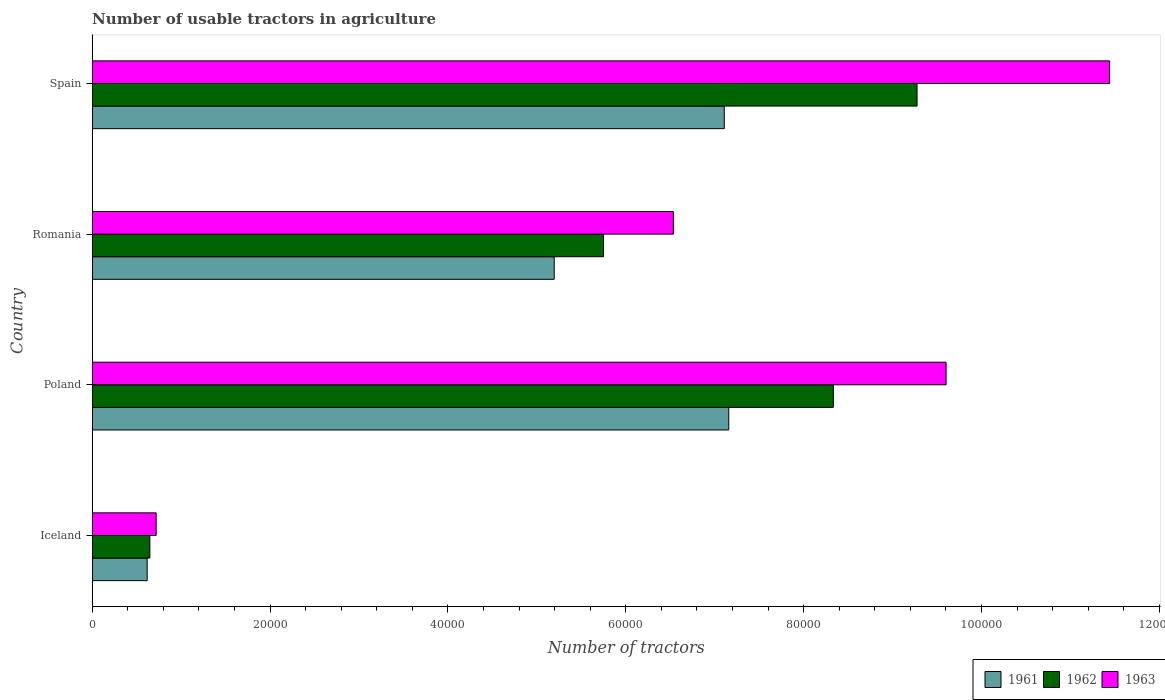How many different coloured bars are there?
Your answer should be compact. 3. Are the number of bars on each tick of the Y-axis equal?
Offer a very short reply. Yes. How many bars are there on the 4th tick from the top?
Offer a terse response. 3. What is the number of usable tractors in agriculture in 1961 in Spain?
Keep it short and to the point. 7.11e+04. Across all countries, what is the maximum number of usable tractors in agriculture in 1963?
Offer a terse response. 1.14e+05. Across all countries, what is the minimum number of usable tractors in agriculture in 1961?
Provide a short and direct response. 6177. In which country was the number of usable tractors in agriculture in 1961 minimum?
Keep it short and to the point. Iceland. What is the total number of usable tractors in agriculture in 1963 in the graph?
Make the answer very short. 2.83e+05. What is the difference between the number of usable tractors in agriculture in 1963 in Iceland and that in Poland?
Keep it short and to the point. -8.88e+04. What is the difference between the number of usable tractors in agriculture in 1961 in Spain and the number of usable tractors in agriculture in 1962 in Iceland?
Keep it short and to the point. 6.46e+04. What is the average number of usable tractors in agriculture in 1962 per country?
Your response must be concise. 6.00e+04. What is the difference between the number of usable tractors in agriculture in 1962 and number of usable tractors in agriculture in 1961 in Iceland?
Make the answer very short. 302. What is the ratio of the number of usable tractors in agriculture in 1961 in Iceland to that in Poland?
Your answer should be very brief. 0.09. Is the difference between the number of usable tractors in agriculture in 1962 in Poland and Spain greater than the difference between the number of usable tractors in agriculture in 1961 in Poland and Spain?
Your answer should be very brief. No. What is the difference between the highest and the lowest number of usable tractors in agriculture in 1961?
Give a very brief answer. 6.54e+04. Is the sum of the number of usable tractors in agriculture in 1961 in Iceland and Spain greater than the maximum number of usable tractors in agriculture in 1962 across all countries?
Your answer should be very brief. No. What does the 3rd bar from the top in Romania represents?
Make the answer very short. 1961. Is it the case that in every country, the sum of the number of usable tractors in agriculture in 1962 and number of usable tractors in agriculture in 1963 is greater than the number of usable tractors in agriculture in 1961?
Keep it short and to the point. Yes. Are all the bars in the graph horizontal?
Keep it short and to the point. Yes. How many countries are there in the graph?
Keep it short and to the point. 4. What is the difference between two consecutive major ticks on the X-axis?
Provide a short and direct response. 2.00e+04. Are the values on the major ticks of X-axis written in scientific E-notation?
Your answer should be very brief. No. Does the graph contain any zero values?
Offer a very short reply. No. Does the graph contain grids?
Your answer should be very brief. No. Where does the legend appear in the graph?
Offer a very short reply. Bottom right. How are the legend labels stacked?
Give a very brief answer. Horizontal. What is the title of the graph?
Make the answer very short. Number of usable tractors in agriculture. What is the label or title of the X-axis?
Offer a very short reply. Number of tractors. What is the Number of tractors in 1961 in Iceland?
Keep it short and to the point. 6177. What is the Number of tractors of 1962 in Iceland?
Offer a terse response. 6479. What is the Number of tractors in 1963 in Iceland?
Offer a very short reply. 7187. What is the Number of tractors of 1961 in Poland?
Your answer should be compact. 7.16e+04. What is the Number of tractors of 1962 in Poland?
Offer a very short reply. 8.33e+04. What is the Number of tractors in 1963 in Poland?
Provide a short and direct response. 9.60e+04. What is the Number of tractors in 1961 in Romania?
Give a very brief answer. 5.20e+04. What is the Number of tractors in 1962 in Romania?
Provide a short and direct response. 5.75e+04. What is the Number of tractors in 1963 in Romania?
Ensure brevity in your answer.  6.54e+04. What is the Number of tractors of 1961 in Spain?
Give a very brief answer. 7.11e+04. What is the Number of tractors in 1962 in Spain?
Offer a very short reply. 9.28e+04. What is the Number of tractors of 1963 in Spain?
Give a very brief answer. 1.14e+05. Across all countries, what is the maximum Number of tractors in 1961?
Provide a short and direct response. 7.16e+04. Across all countries, what is the maximum Number of tractors in 1962?
Provide a succinct answer. 9.28e+04. Across all countries, what is the maximum Number of tractors in 1963?
Your answer should be compact. 1.14e+05. Across all countries, what is the minimum Number of tractors of 1961?
Give a very brief answer. 6177. Across all countries, what is the minimum Number of tractors of 1962?
Your answer should be compact. 6479. Across all countries, what is the minimum Number of tractors in 1963?
Your answer should be very brief. 7187. What is the total Number of tractors of 1961 in the graph?
Make the answer very short. 2.01e+05. What is the total Number of tractors of 1962 in the graph?
Your answer should be very brief. 2.40e+05. What is the total Number of tractors of 1963 in the graph?
Offer a very short reply. 2.83e+05. What is the difference between the Number of tractors in 1961 in Iceland and that in Poland?
Offer a terse response. -6.54e+04. What is the difference between the Number of tractors in 1962 in Iceland and that in Poland?
Your response must be concise. -7.69e+04. What is the difference between the Number of tractors in 1963 in Iceland and that in Poland?
Provide a short and direct response. -8.88e+04. What is the difference between the Number of tractors of 1961 in Iceland and that in Romania?
Your response must be concise. -4.58e+04. What is the difference between the Number of tractors in 1962 in Iceland and that in Romania?
Your answer should be very brief. -5.10e+04. What is the difference between the Number of tractors of 1963 in Iceland and that in Romania?
Give a very brief answer. -5.82e+04. What is the difference between the Number of tractors of 1961 in Iceland and that in Spain?
Ensure brevity in your answer.  -6.49e+04. What is the difference between the Number of tractors of 1962 in Iceland and that in Spain?
Your answer should be very brief. -8.63e+04. What is the difference between the Number of tractors in 1963 in Iceland and that in Spain?
Keep it short and to the point. -1.07e+05. What is the difference between the Number of tractors of 1961 in Poland and that in Romania?
Provide a short and direct response. 1.96e+04. What is the difference between the Number of tractors of 1962 in Poland and that in Romania?
Your answer should be compact. 2.58e+04. What is the difference between the Number of tractors in 1963 in Poland and that in Romania?
Your response must be concise. 3.07e+04. What is the difference between the Number of tractors of 1962 in Poland and that in Spain?
Offer a terse response. -9414. What is the difference between the Number of tractors in 1963 in Poland and that in Spain?
Give a very brief answer. -1.84e+04. What is the difference between the Number of tractors of 1961 in Romania and that in Spain?
Ensure brevity in your answer.  -1.91e+04. What is the difference between the Number of tractors in 1962 in Romania and that in Spain?
Give a very brief answer. -3.53e+04. What is the difference between the Number of tractors of 1963 in Romania and that in Spain?
Offer a very short reply. -4.91e+04. What is the difference between the Number of tractors in 1961 in Iceland and the Number of tractors in 1962 in Poland?
Your response must be concise. -7.72e+04. What is the difference between the Number of tractors in 1961 in Iceland and the Number of tractors in 1963 in Poland?
Keep it short and to the point. -8.98e+04. What is the difference between the Number of tractors of 1962 in Iceland and the Number of tractors of 1963 in Poland?
Give a very brief answer. -8.95e+04. What is the difference between the Number of tractors of 1961 in Iceland and the Number of tractors of 1962 in Romania?
Your answer should be very brief. -5.13e+04. What is the difference between the Number of tractors of 1961 in Iceland and the Number of tractors of 1963 in Romania?
Make the answer very short. -5.92e+04. What is the difference between the Number of tractors of 1962 in Iceland and the Number of tractors of 1963 in Romania?
Your answer should be compact. -5.89e+04. What is the difference between the Number of tractors of 1961 in Iceland and the Number of tractors of 1962 in Spain?
Your response must be concise. -8.66e+04. What is the difference between the Number of tractors of 1961 in Iceland and the Number of tractors of 1963 in Spain?
Offer a very short reply. -1.08e+05. What is the difference between the Number of tractors of 1962 in Iceland and the Number of tractors of 1963 in Spain?
Your response must be concise. -1.08e+05. What is the difference between the Number of tractors of 1961 in Poland and the Number of tractors of 1962 in Romania?
Provide a succinct answer. 1.41e+04. What is the difference between the Number of tractors in 1961 in Poland and the Number of tractors in 1963 in Romania?
Your answer should be very brief. 6226. What is the difference between the Number of tractors in 1962 in Poland and the Number of tractors in 1963 in Romania?
Your response must be concise. 1.80e+04. What is the difference between the Number of tractors of 1961 in Poland and the Number of tractors of 1962 in Spain?
Provide a succinct answer. -2.12e+04. What is the difference between the Number of tractors in 1961 in Poland and the Number of tractors in 1963 in Spain?
Give a very brief answer. -4.28e+04. What is the difference between the Number of tractors in 1962 in Poland and the Number of tractors in 1963 in Spain?
Provide a short and direct response. -3.11e+04. What is the difference between the Number of tractors in 1961 in Romania and the Number of tractors in 1962 in Spain?
Provide a short and direct response. -4.08e+04. What is the difference between the Number of tractors in 1961 in Romania and the Number of tractors in 1963 in Spain?
Your answer should be compact. -6.25e+04. What is the difference between the Number of tractors in 1962 in Romania and the Number of tractors in 1963 in Spain?
Provide a short and direct response. -5.69e+04. What is the average Number of tractors of 1961 per country?
Ensure brevity in your answer.  5.02e+04. What is the average Number of tractors of 1962 per country?
Your response must be concise. 6.00e+04. What is the average Number of tractors in 1963 per country?
Offer a very short reply. 7.07e+04. What is the difference between the Number of tractors in 1961 and Number of tractors in 1962 in Iceland?
Offer a terse response. -302. What is the difference between the Number of tractors of 1961 and Number of tractors of 1963 in Iceland?
Offer a very short reply. -1010. What is the difference between the Number of tractors in 1962 and Number of tractors in 1963 in Iceland?
Make the answer very short. -708. What is the difference between the Number of tractors in 1961 and Number of tractors in 1962 in Poland?
Offer a very short reply. -1.18e+04. What is the difference between the Number of tractors in 1961 and Number of tractors in 1963 in Poland?
Keep it short and to the point. -2.44e+04. What is the difference between the Number of tractors in 1962 and Number of tractors in 1963 in Poland?
Your answer should be very brief. -1.27e+04. What is the difference between the Number of tractors in 1961 and Number of tractors in 1962 in Romania?
Give a very brief answer. -5548. What is the difference between the Number of tractors of 1961 and Number of tractors of 1963 in Romania?
Give a very brief answer. -1.34e+04. What is the difference between the Number of tractors of 1962 and Number of tractors of 1963 in Romania?
Provide a short and direct response. -7851. What is the difference between the Number of tractors in 1961 and Number of tractors in 1962 in Spain?
Keep it short and to the point. -2.17e+04. What is the difference between the Number of tractors of 1961 and Number of tractors of 1963 in Spain?
Provide a short and direct response. -4.33e+04. What is the difference between the Number of tractors in 1962 and Number of tractors in 1963 in Spain?
Offer a very short reply. -2.17e+04. What is the ratio of the Number of tractors of 1961 in Iceland to that in Poland?
Give a very brief answer. 0.09. What is the ratio of the Number of tractors in 1962 in Iceland to that in Poland?
Ensure brevity in your answer.  0.08. What is the ratio of the Number of tractors of 1963 in Iceland to that in Poland?
Keep it short and to the point. 0.07. What is the ratio of the Number of tractors of 1961 in Iceland to that in Romania?
Give a very brief answer. 0.12. What is the ratio of the Number of tractors in 1962 in Iceland to that in Romania?
Your response must be concise. 0.11. What is the ratio of the Number of tractors of 1963 in Iceland to that in Romania?
Make the answer very short. 0.11. What is the ratio of the Number of tractors in 1961 in Iceland to that in Spain?
Provide a succinct answer. 0.09. What is the ratio of the Number of tractors of 1962 in Iceland to that in Spain?
Give a very brief answer. 0.07. What is the ratio of the Number of tractors in 1963 in Iceland to that in Spain?
Provide a succinct answer. 0.06. What is the ratio of the Number of tractors in 1961 in Poland to that in Romania?
Your answer should be compact. 1.38. What is the ratio of the Number of tractors of 1962 in Poland to that in Romania?
Provide a succinct answer. 1.45. What is the ratio of the Number of tractors of 1963 in Poland to that in Romania?
Make the answer very short. 1.47. What is the ratio of the Number of tractors in 1961 in Poland to that in Spain?
Offer a very short reply. 1.01. What is the ratio of the Number of tractors in 1962 in Poland to that in Spain?
Make the answer very short. 0.9. What is the ratio of the Number of tractors of 1963 in Poland to that in Spain?
Offer a very short reply. 0.84. What is the ratio of the Number of tractors in 1961 in Romania to that in Spain?
Your answer should be very brief. 0.73. What is the ratio of the Number of tractors of 1962 in Romania to that in Spain?
Keep it short and to the point. 0.62. What is the ratio of the Number of tractors of 1963 in Romania to that in Spain?
Provide a short and direct response. 0.57. What is the difference between the highest and the second highest Number of tractors in 1962?
Offer a terse response. 9414. What is the difference between the highest and the second highest Number of tractors of 1963?
Offer a terse response. 1.84e+04. What is the difference between the highest and the lowest Number of tractors in 1961?
Offer a very short reply. 6.54e+04. What is the difference between the highest and the lowest Number of tractors in 1962?
Make the answer very short. 8.63e+04. What is the difference between the highest and the lowest Number of tractors of 1963?
Make the answer very short. 1.07e+05. 